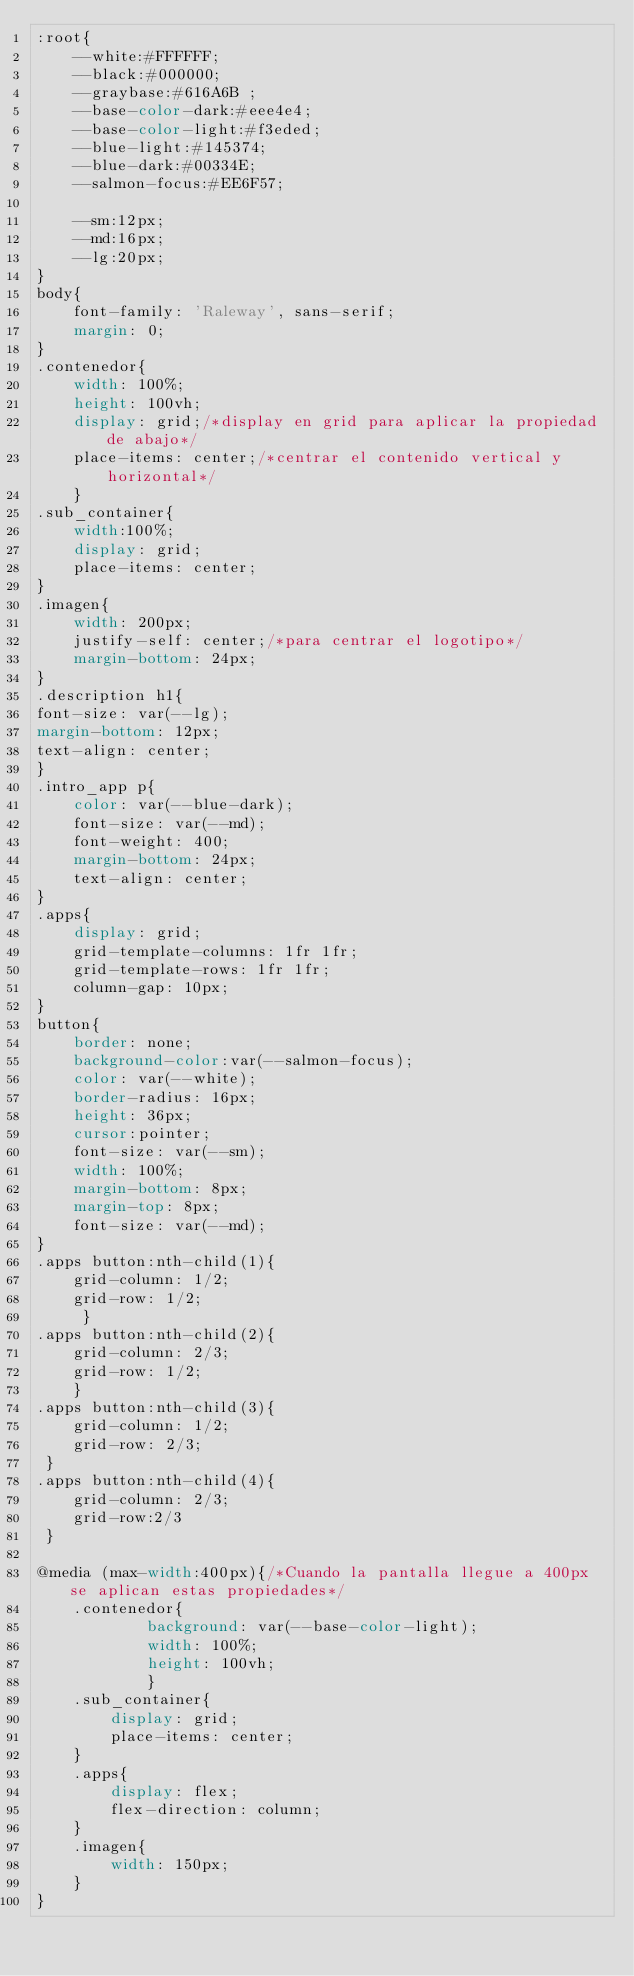Convert code to text. <code><loc_0><loc_0><loc_500><loc_500><_CSS_>:root{
    --white:#FFFFFF;
    --black:#000000;
    --graybase:#616A6B ;
    --base-color-dark:#eee4e4;
    --base-color-light:#f3eded;
    --blue-light:#145374;
    --blue-dark:#00334E;
    --salmon-focus:#EE6F57;

    --sm:12px;
    --md:16px;
    --lg:20px;
}
body{
    font-family: 'Raleway', sans-serif;
    margin: 0;
}
.contenedor{
    width: 100%;
    height: 100vh;
    display: grid;/*display en grid para aplicar la propiedad de abajo*/
    place-items: center;/*centrar el contenido vertical y horizontal*/
    }
.sub_container{
    width:100%;
    display: grid;
    place-items: center;
}
.imagen{
    width: 200px;
    justify-self: center;/*para centrar el logotipo*/
    margin-bottom: 24px;
}
.description h1{
font-size: var(--lg);
margin-bottom: 12px;
text-align: center;
}
.intro_app p{
    color: var(--blue-dark);
    font-size: var(--md);
    font-weight: 400;
    margin-bottom: 24px;
    text-align: center;
}
.apps{
    display: grid;
    grid-template-columns: 1fr 1fr;
    grid-template-rows: 1fr 1fr;
    column-gap: 10px;
}
button{
    border: none;
    background-color:var(--salmon-focus);
    color: var(--white);
    border-radius: 16px;
    height: 36px;
    cursor:pointer;
    font-size: var(--sm);
    width: 100%;
    margin-bottom: 8px;
    margin-top: 8px;
    font-size: var(--md);
}
.apps button:nth-child(1){
    grid-column: 1/2;
    grid-row: 1/2;
     }
.apps button:nth-child(2){
    grid-column: 2/3;
    grid-row: 1/2;
    }
.apps button:nth-child(3){ 
    grid-column: 1/2;
    grid-row: 2/3;
 }
.apps button:nth-child(4){   
    grid-column: 2/3;
    grid-row:2/3
 }

@media (max-width:400px){/*Cuando la pantalla llegue a 400px se aplican estas propiedades*/
    .contenedor{
            background: var(--base-color-light);
            width: 100%;
            height: 100vh;
            }
    .sub_container{
        display: grid;
        place-items: center;
    }
    .apps{
        display: flex;
        flex-direction: column;
    }
    .imagen{
        width: 150px;
    }
}</code> 